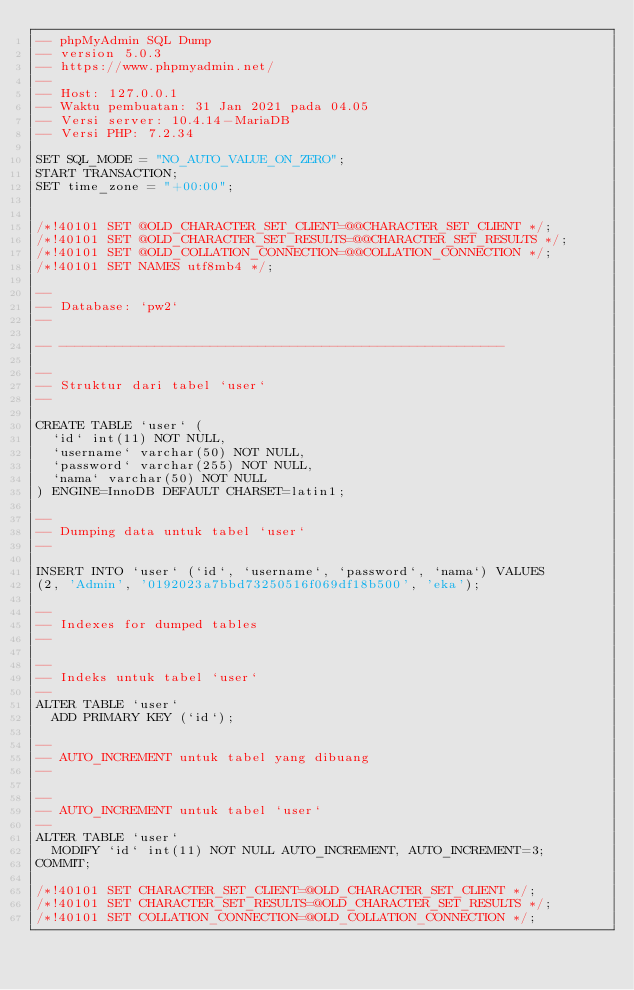<code> <loc_0><loc_0><loc_500><loc_500><_SQL_>-- phpMyAdmin SQL Dump
-- version 5.0.3
-- https://www.phpmyadmin.net/
--
-- Host: 127.0.0.1
-- Waktu pembuatan: 31 Jan 2021 pada 04.05
-- Versi server: 10.4.14-MariaDB
-- Versi PHP: 7.2.34

SET SQL_MODE = "NO_AUTO_VALUE_ON_ZERO";
START TRANSACTION;
SET time_zone = "+00:00";


/*!40101 SET @OLD_CHARACTER_SET_CLIENT=@@CHARACTER_SET_CLIENT */;
/*!40101 SET @OLD_CHARACTER_SET_RESULTS=@@CHARACTER_SET_RESULTS */;
/*!40101 SET @OLD_COLLATION_CONNECTION=@@COLLATION_CONNECTION */;
/*!40101 SET NAMES utf8mb4 */;

--
-- Database: `pw2`
--

-- --------------------------------------------------------

--
-- Struktur dari tabel `user`
--

CREATE TABLE `user` (
  `id` int(11) NOT NULL,
  `username` varchar(50) NOT NULL,
  `password` varchar(255) NOT NULL,
  `nama` varchar(50) NOT NULL
) ENGINE=InnoDB DEFAULT CHARSET=latin1;

--
-- Dumping data untuk tabel `user`
--

INSERT INTO `user` (`id`, `username`, `password`, `nama`) VALUES
(2, 'Admin', '0192023a7bbd73250516f069df18b500', 'eka');

--
-- Indexes for dumped tables
--

--
-- Indeks untuk tabel `user`
--
ALTER TABLE `user`
  ADD PRIMARY KEY (`id`);

--
-- AUTO_INCREMENT untuk tabel yang dibuang
--

--
-- AUTO_INCREMENT untuk tabel `user`
--
ALTER TABLE `user`
  MODIFY `id` int(11) NOT NULL AUTO_INCREMENT, AUTO_INCREMENT=3;
COMMIT;

/*!40101 SET CHARACTER_SET_CLIENT=@OLD_CHARACTER_SET_CLIENT */;
/*!40101 SET CHARACTER_SET_RESULTS=@OLD_CHARACTER_SET_RESULTS */;
/*!40101 SET COLLATION_CONNECTION=@OLD_COLLATION_CONNECTION */;
</code> 